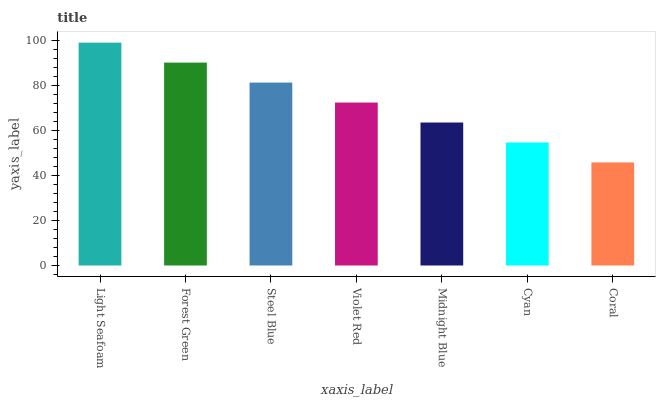Is Coral the minimum?
Answer yes or no. Yes. Is Light Seafoam the maximum?
Answer yes or no. Yes. Is Forest Green the minimum?
Answer yes or no. No. Is Forest Green the maximum?
Answer yes or no. No. Is Light Seafoam greater than Forest Green?
Answer yes or no. Yes. Is Forest Green less than Light Seafoam?
Answer yes or no. Yes. Is Forest Green greater than Light Seafoam?
Answer yes or no. No. Is Light Seafoam less than Forest Green?
Answer yes or no. No. Is Violet Red the high median?
Answer yes or no. Yes. Is Violet Red the low median?
Answer yes or no. Yes. Is Midnight Blue the high median?
Answer yes or no. No. Is Light Seafoam the low median?
Answer yes or no. No. 